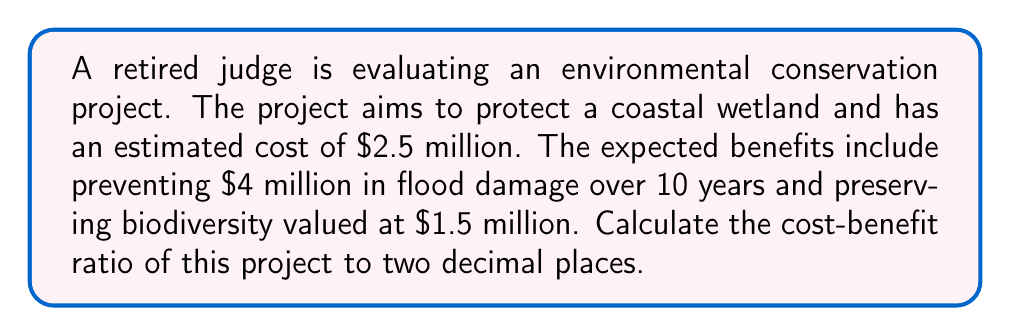Teach me how to tackle this problem. To calculate the cost-benefit ratio, we need to follow these steps:

1. Calculate the total benefits:
   Total benefits = Flood damage prevention + Biodiversity preservation
   $$ \text{Total benefits} = \$4,000,000 + \$1,500,000 = \$5,500,000 $$

2. Calculate the cost-benefit ratio:
   Cost-benefit ratio = Total benefits / Total costs
   $$ \text{Cost-benefit ratio} = \frac{\$5,500,000}{\$2,500,000} = 2.2 $$

3. Round the result to two decimal places:
   The cost-benefit ratio is already expressed to two decimal places, so no further rounding is necessary.

A cost-benefit ratio greater than 1 indicates that the benefits outweigh the costs, making the project economically viable. In this case, the ratio of 2.2 suggests that for every dollar spent on the project, $2.20 in benefits is expected to be generated.
Answer: 2.2 